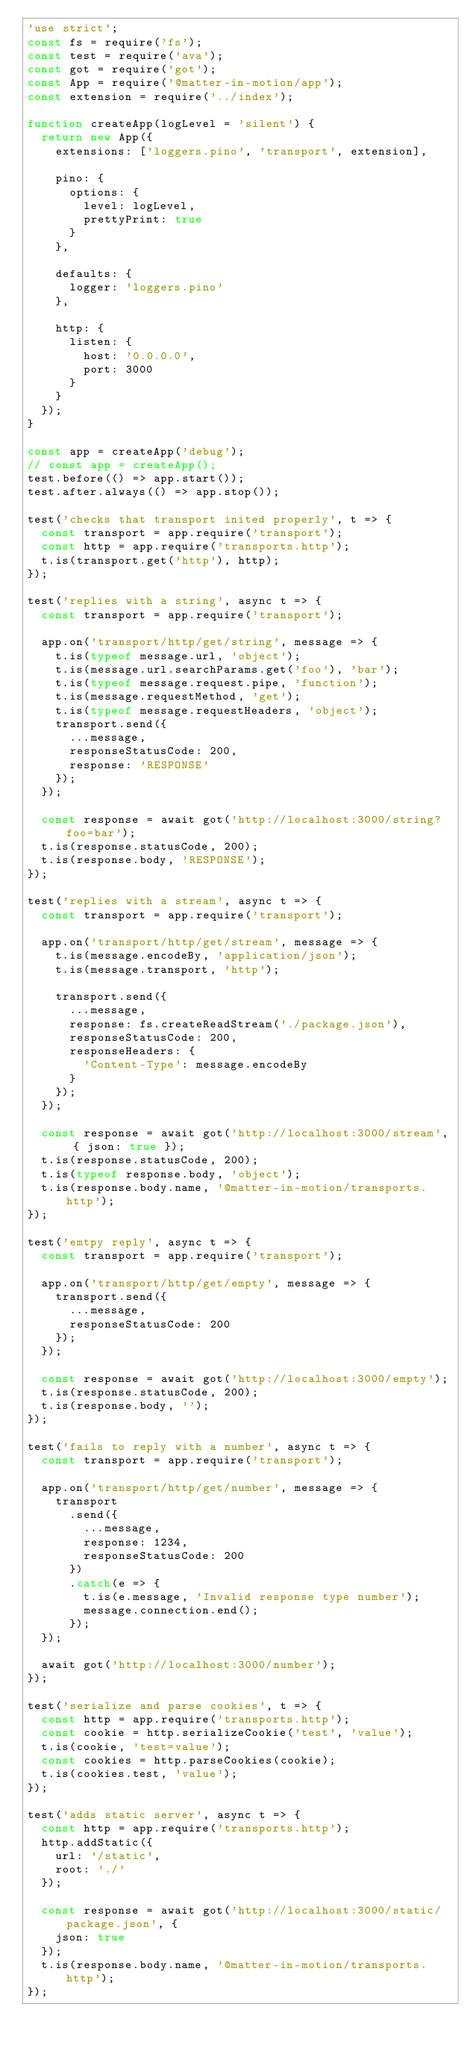<code> <loc_0><loc_0><loc_500><loc_500><_JavaScript_>'use strict';
const fs = require('fs');
const test = require('ava');
const got = require('got');
const App = require('@matter-in-motion/app');
const extension = require('../index');

function createApp(logLevel = 'silent') {
  return new App({
    extensions: ['loggers.pino', 'transport', extension],

    pino: {
      options: {
        level: logLevel,
        prettyPrint: true
      }
    },

    defaults: {
      logger: 'loggers.pino'
    },

    http: {
      listen: {
        host: '0.0.0.0',
        port: 3000
      }
    }
  });
}

const app = createApp('debug');
// const app = createApp();
test.before(() => app.start());
test.after.always(() => app.stop());

test('checks that transport inited properly', t => {
  const transport = app.require('transport');
  const http = app.require('transports.http');
  t.is(transport.get('http'), http);
});

test('replies with a string', async t => {
  const transport = app.require('transport');

  app.on('transport/http/get/string', message => {
    t.is(typeof message.url, 'object');
    t.is(message.url.searchParams.get('foo'), 'bar');
    t.is(typeof message.request.pipe, 'function');
    t.is(message.requestMethod, 'get');
    t.is(typeof message.requestHeaders, 'object');
    transport.send({
      ...message,
      responseStatusCode: 200,
      response: 'RESPONSE'
    });
  });

  const response = await got('http://localhost:3000/string?foo=bar');
  t.is(response.statusCode, 200);
  t.is(response.body, 'RESPONSE');
});

test('replies with a stream', async t => {
  const transport = app.require('transport');

  app.on('transport/http/get/stream', message => {
    t.is(message.encodeBy, 'application/json');
    t.is(message.transport, 'http');

    transport.send({
      ...message,
      response: fs.createReadStream('./package.json'),
      responseStatusCode: 200,
      responseHeaders: {
        'Content-Type': message.encodeBy
      }
    });
  });

  const response = await got('http://localhost:3000/stream', { json: true });
  t.is(response.statusCode, 200);
  t.is(typeof response.body, 'object');
  t.is(response.body.name, '@matter-in-motion/transports.http');
});

test('emtpy reply', async t => {
  const transport = app.require('transport');

  app.on('transport/http/get/empty', message => {
    transport.send({
      ...message,
      responseStatusCode: 200
    });
  });

  const response = await got('http://localhost:3000/empty');
  t.is(response.statusCode, 200);
  t.is(response.body, '');
});

test('fails to reply with a number', async t => {
  const transport = app.require('transport');

  app.on('transport/http/get/number', message => {
    transport
      .send({
        ...message,
        response: 1234,
        responseStatusCode: 200
      })
      .catch(e => {
        t.is(e.message, 'Invalid response type number');
        message.connection.end();
      });
  });

  await got('http://localhost:3000/number');
});

test('serialize and parse cookies', t => {
  const http = app.require('transports.http');
  const cookie = http.serializeCookie('test', 'value');
  t.is(cookie, 'test=value');
  const cookies = http.parseCookies(cookie);
  t.is(cookies.test, 'value');
});

test('adds static server', async t => {
  const http = app.require('transports.http');
  http.addStatic({
    url: '/static',
    root: './'
  });

  const response = await got('http://localhost:3000/static/package.json', {
    json: true
  });
  t.is(response.body.name, '@matter-in-motion/transports.http');
});
</code> 